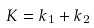<formula> <loc_0><loc_0><loc_500><loc_500>K = k _ { 1 } + k _ { 2 }</formula> 